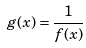<formula> <loc_0><loc_0><loc_500><loc_500>g ( x ) = \frac { 1 } { f ( x ) }</formula> 